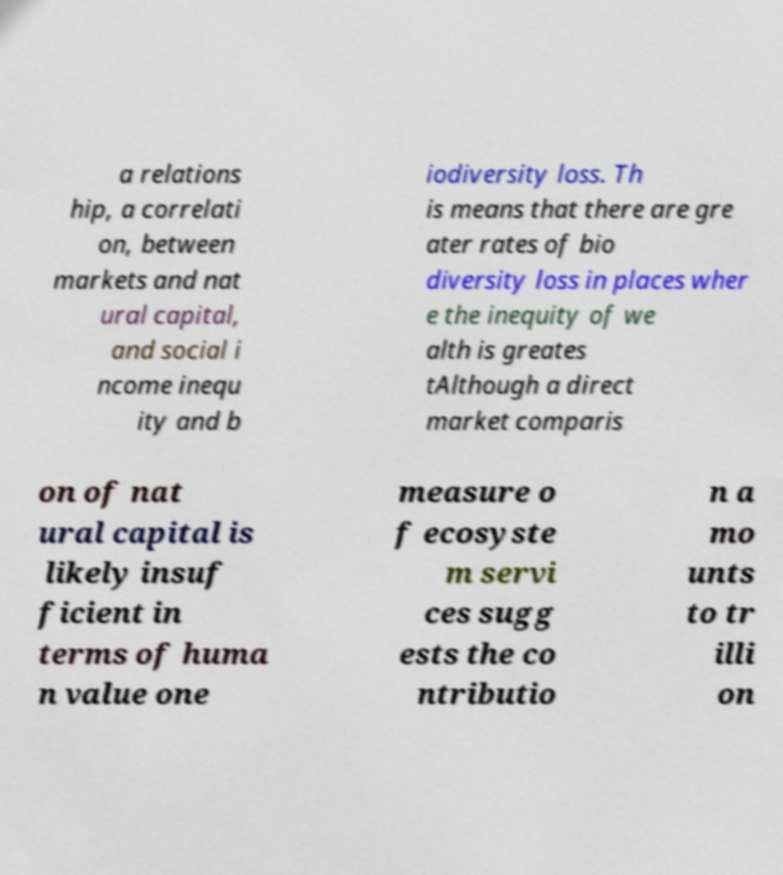There's text embedded in this image that I need extracted. Can you transcribe it verbatim? a relations hip, a correlati on, between markets and nat ural capital, and social i ncome inequ ity and b iodiversity loss. Th is means that there are gre ater rates of bio diversity loss in places wher e the inequity of we alth is greates tAlthough a direct market comparis on of nat ural capital is likely insuf ficient in terms of huma n value one measure o f ecosyste m servi ces sugg ests the co ntributio n a mo unts to tr illi on 